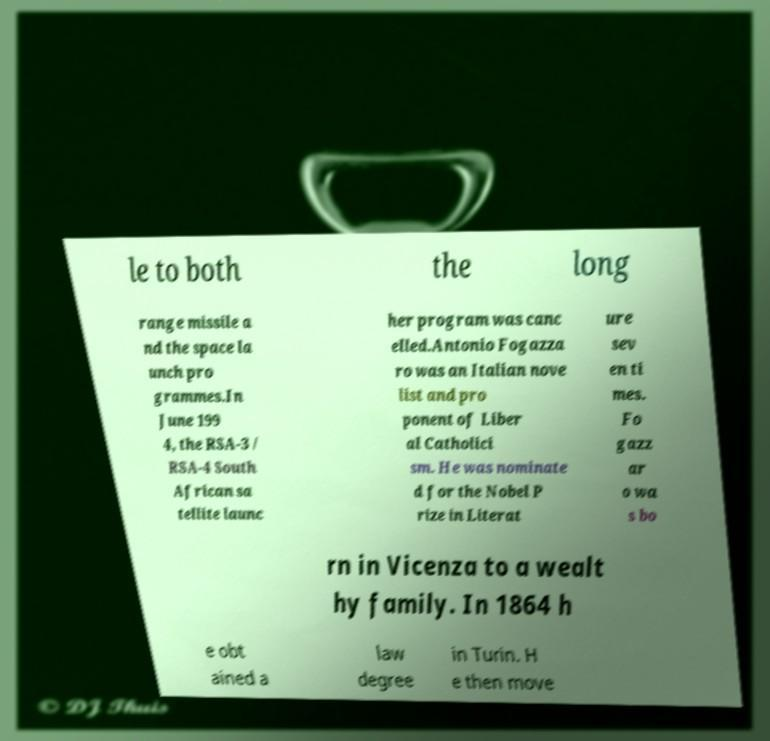For documentation purposes, I need the text within this image transcribed. Could you provide that? le to both the long range missile a nd the space la unch pro grammes.In June 199 4, the RSA-3 / RSA-4 South African sa tellite launc her program was canc elled.Antonio Fogazza ro was an Italian nove list and pro ponent of Liber al Catholici sm. He was nominate d for the Nobel P rize in Literat ure sev en ti mes. Fo gazz ar o wa s bo rn in Vicenza to a wealt hy family. In 1864 h e obt ained a law degree in Turin. H e then move 